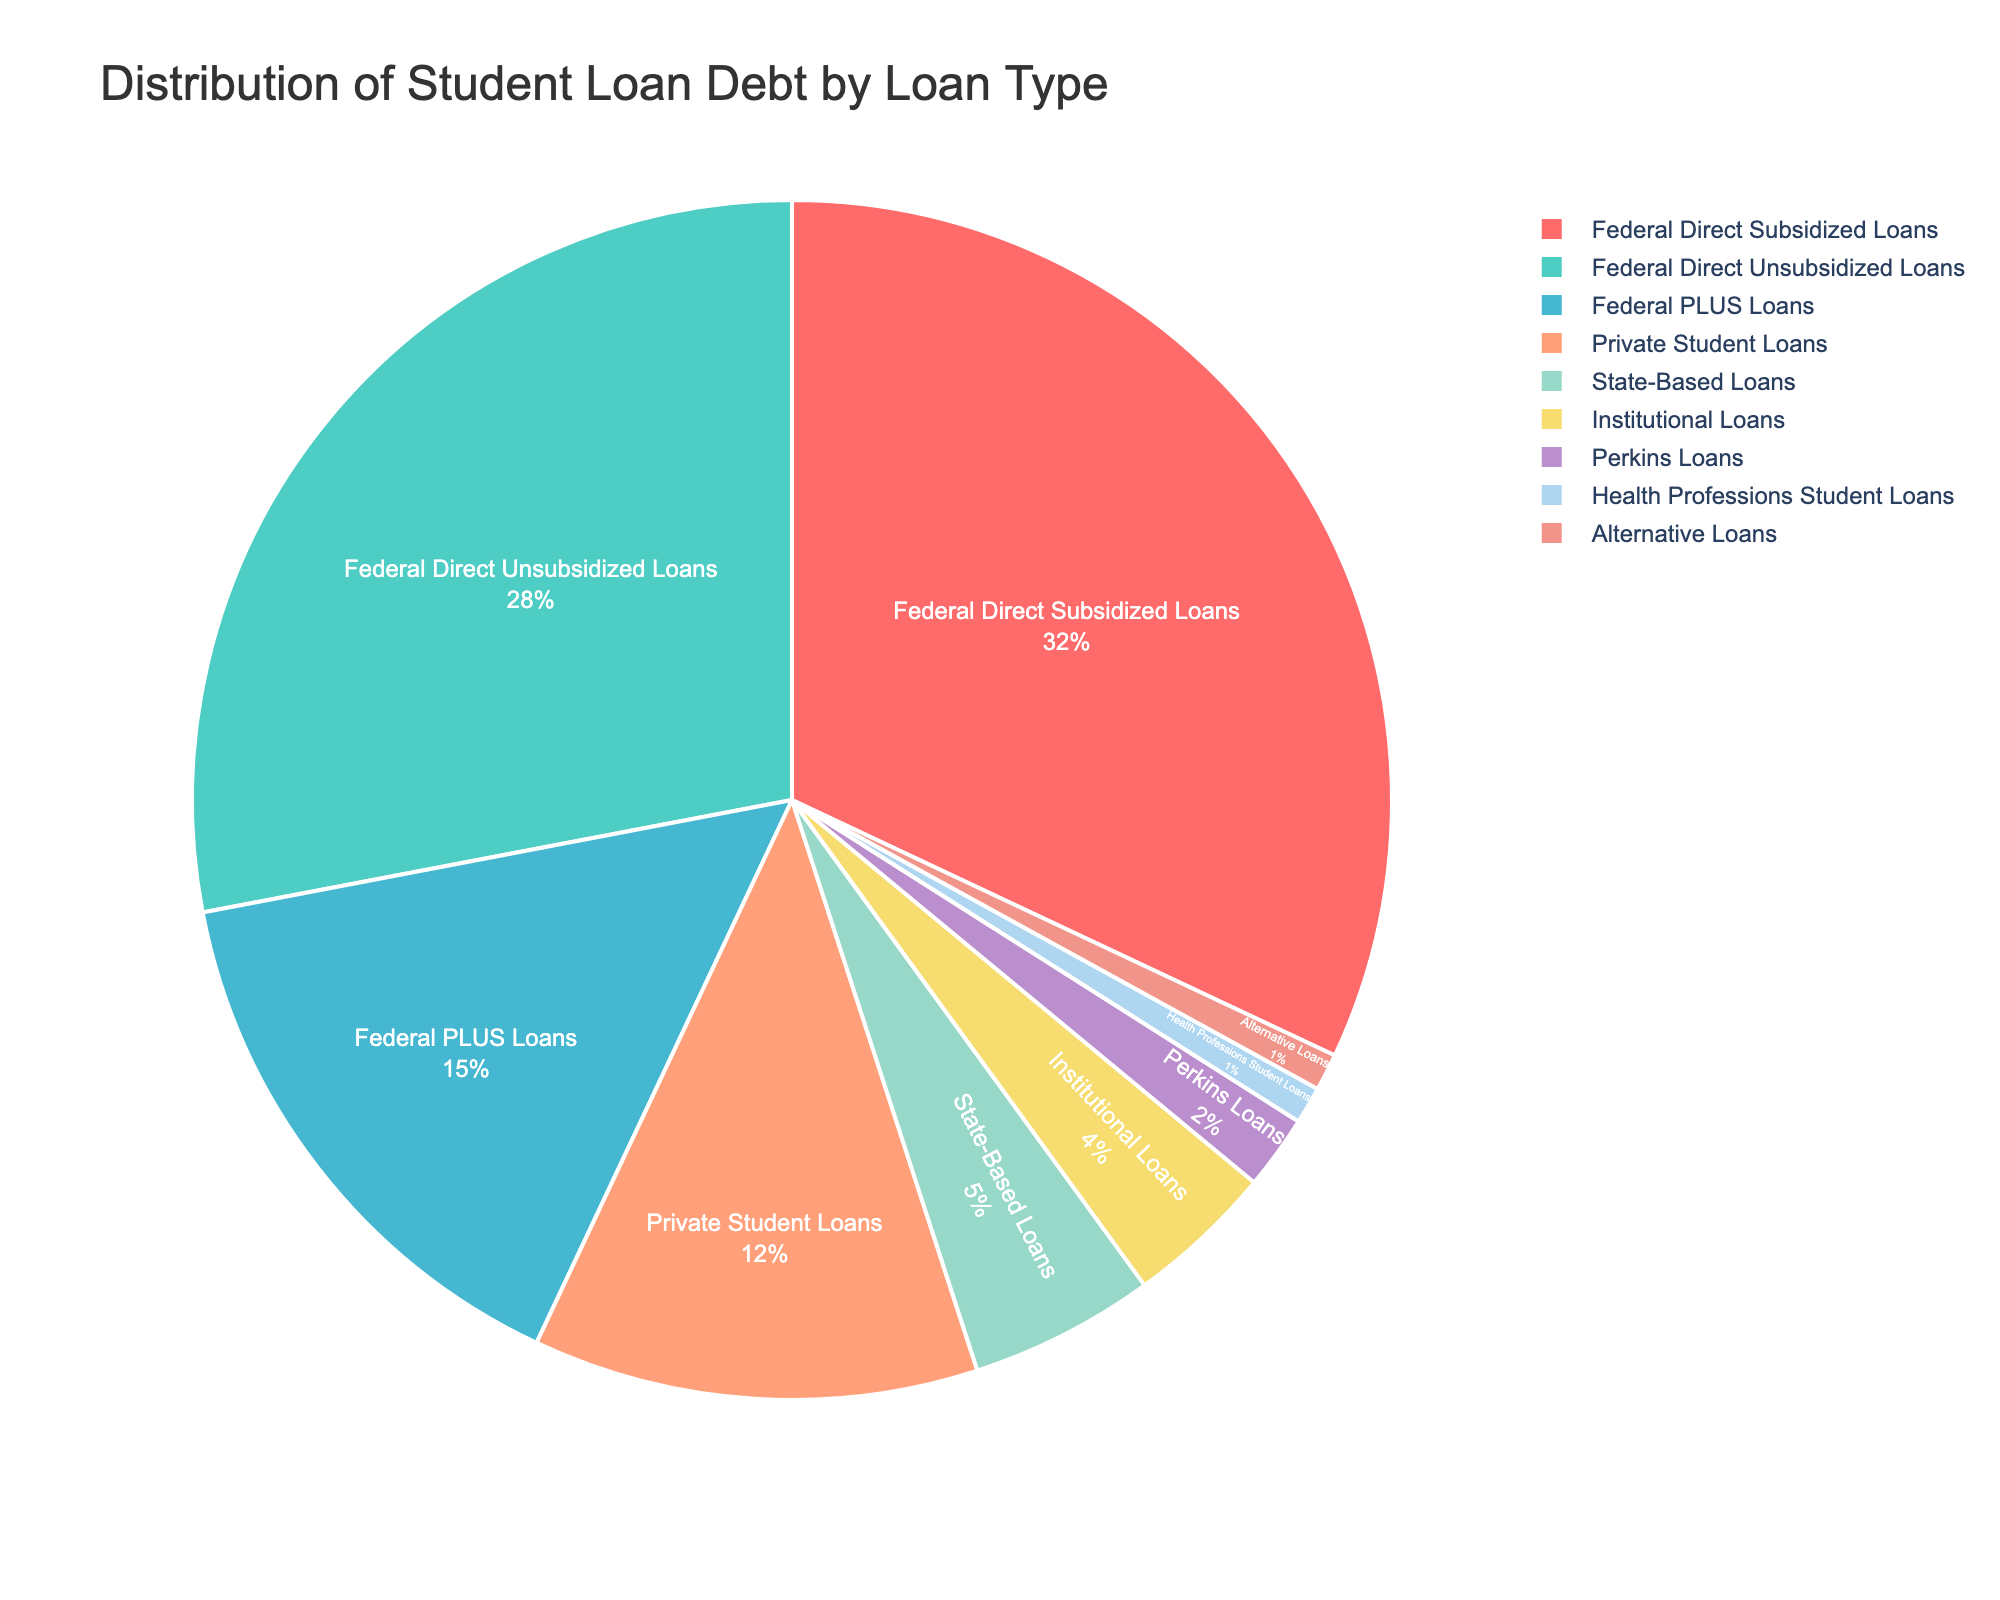What percentage of the total loan debt is made up by Federal Direct Loans? To determine this, sum the percentages of Federal Direct Subsidized Loans and Federal Direct Unsubsidized Loans: 32% + 28%.
Answer: 60% Which loan type has the lowest percentage of student loan debt? By looking at the pie chart, we identify that Health Professions Student Loans and Alternative Loans both have the lowest percentage at 1% each.
Answer: Health Professions Student Loans and Alternative Loans What is the difference in percentage between Federal PLUS Loans and Private Student Loans? Subtract the percentage of Private Student Loans from Federal PLUS Loans: 15% - 12%.
Answer: 3% Which category represents a larger percentage of the student loan debt: State-Based Loans or Institutional Loans? Compare the percentages of State-Based Loans (5%) and Institutional Loans (4%), and identify which is larger.
Answer: State-Based Loans Are Federal PLUS Loans more or less than twice the percentage of Perkins Loans? Calculate twice the percentage of Perkins Loans: 2% * 2 = 4%. Compare Federal PLUS Loans (15%) to 4%.
Answer: More What percentage of loan debt is made up by the combination of Private Student Loans and State-Based Loans? Sum the percentages of Private Student Loans and State-Based Loans: 12% + 5%.
Answer: 17% Of the listed loan types, which has more loan debt: Federal Direct Unsubsidized Loans or the combined total of Perkins Loans and Health Professions Student Loans? Compare Federal Direct Unsubsidized Loans (28%) to the sum of Perkins Loans and Health Professions Student Loans: 2% + 1% = 3%.
Answer: Federal Direct Unsubsidized Loans What color is used to represent Federal Direct Subsidized Loans in the pie chart? Visually identifying on the chart, Federal Direct Subsidized Loans are represented by the first color listed, which is red.
Answer: Red 